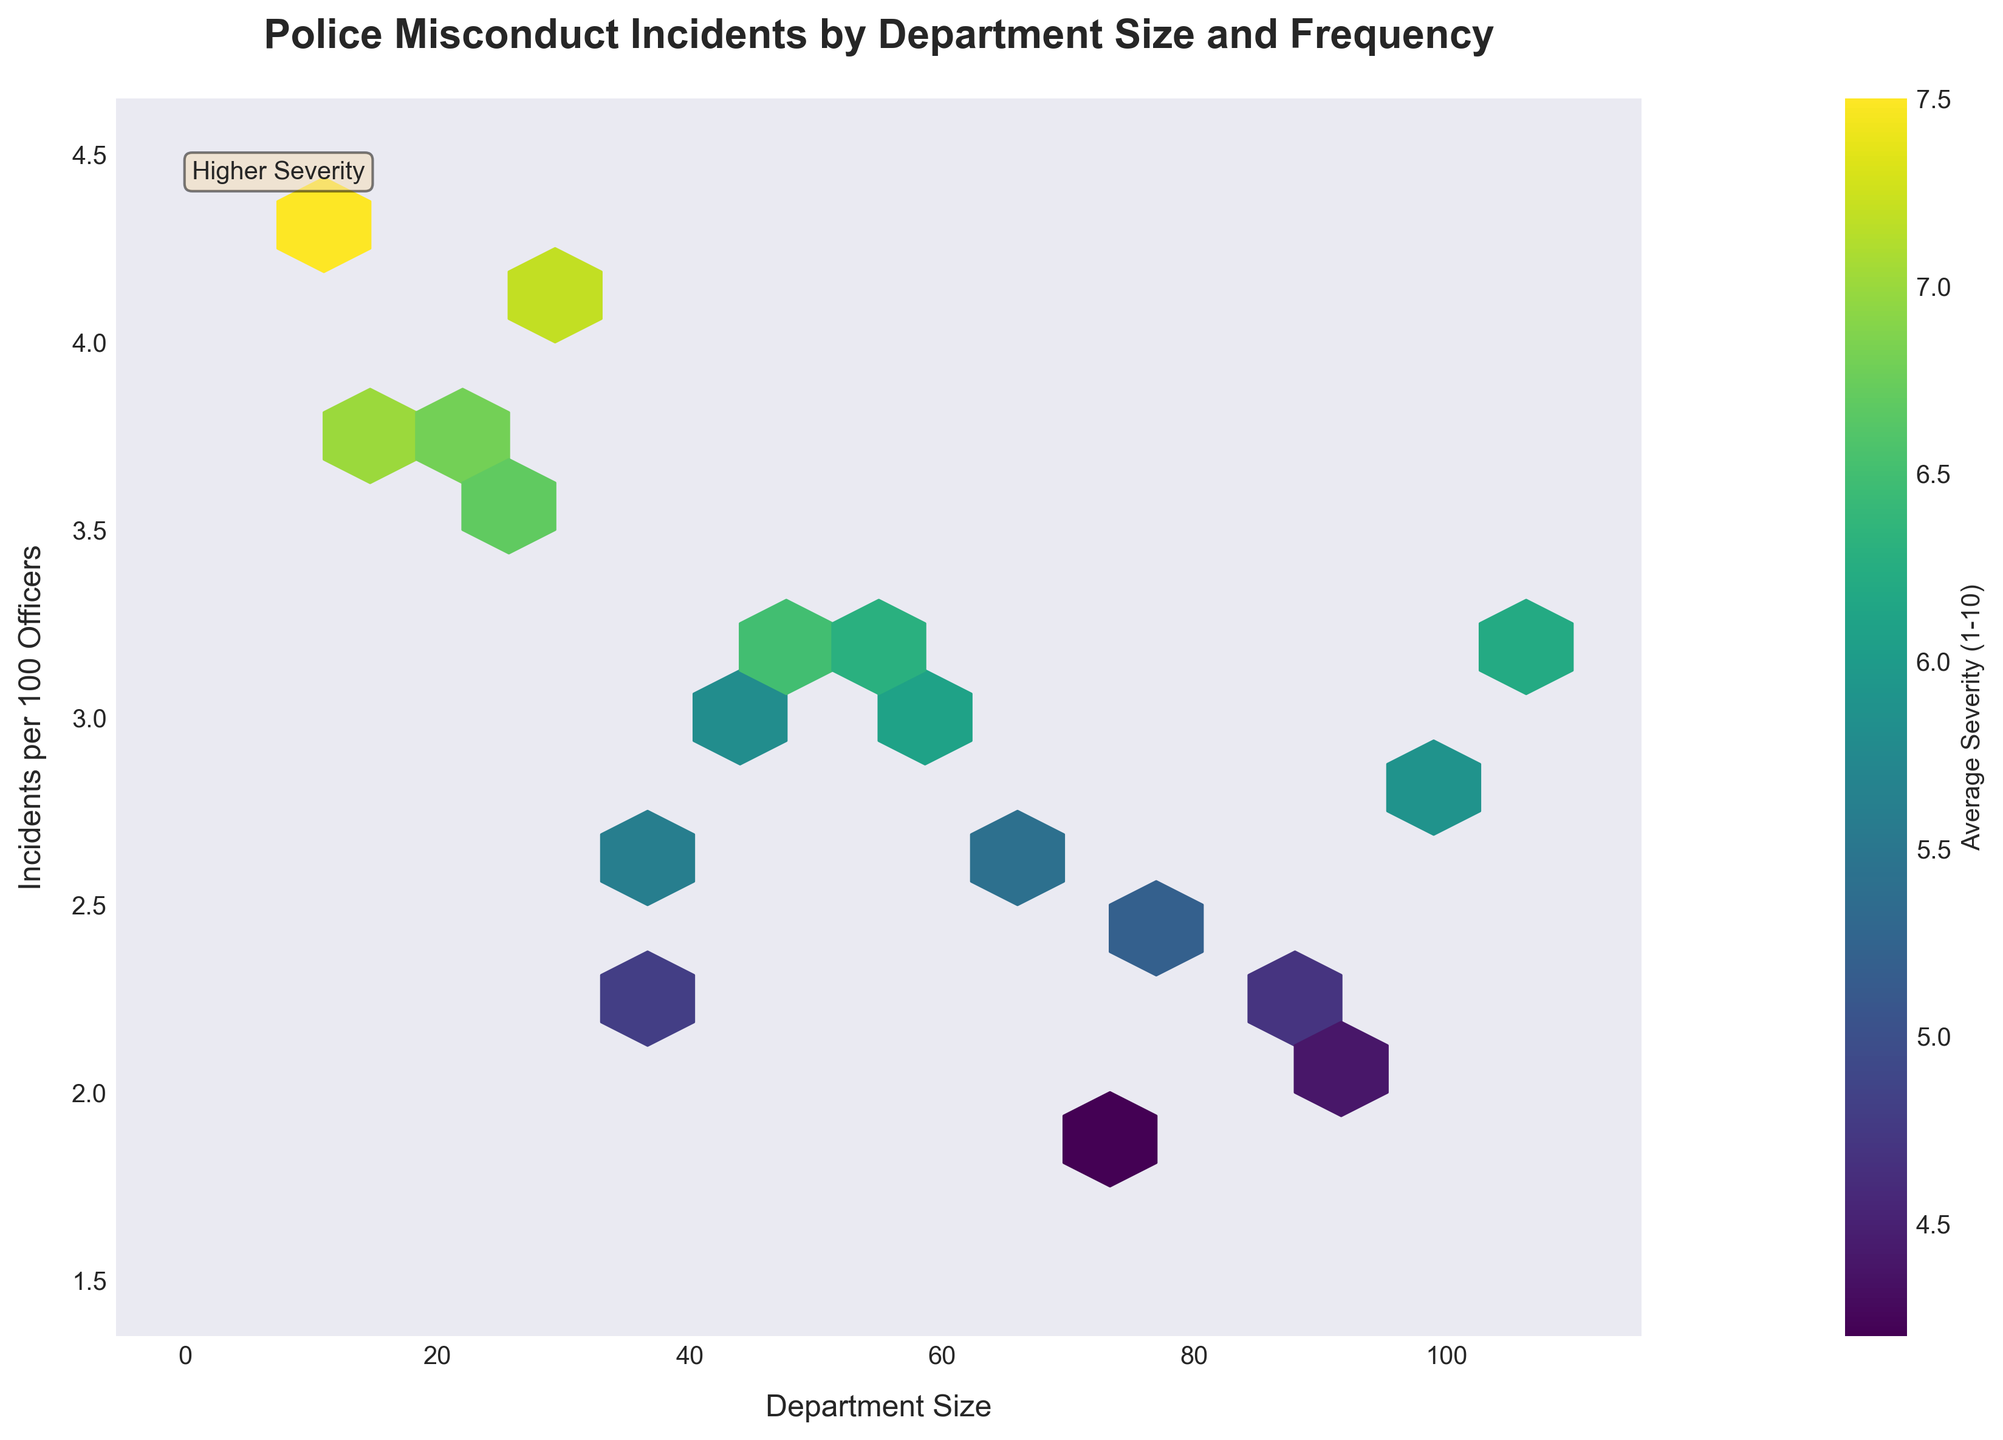What is the title of the figure? The title is typically displayed at the top of the figure, summarizing the main subject of the plot.
Answer: Police Misconduct Incidents by Department Size and Frequency What is the color used to indicate higher severity? Observing the color bar on the right side of the plot will show the gradient of colors representing different severities. The color for higher severity is usually darker or more intense.
Answer: Dark purple What are the axes labels? The labels on the axes are usually positioned next to the axes themselves and explain what each axis represents.
Answer: Department Size (x-axis), Incidents per 100 Officers (y-axis) Between which two values is the frequency of incidents per 100 officers mostly distributed? Check the density of hexagons along the y-axis which indicates the frequency of incidents per 100 officers.
Answer: 2 to 4 Which department size corresponds to the highest average severity? Look for the darkest hexagons on the plot and match them with their department size on the x-axis.
Answer: Denver (10 officers) Is there a positive or negative correlation between department size and incidents per 100 officers? Observe the general trend of hexagons to see if an increase in department size corresponds with an increase or decrease in incidents per 100 officers.
Answer: Negative correlation Which department size range (large or small) tends to have higher severity of incidents? Compare the color distribution across the hexagons, noting which side of the plot has darker colors.
Answer: Small department sizes Do smaller or larger departments have more variability in severity of incidents? Look at the range of colors (indicating severity) in regions representing smaller versus larger department sizes.
Answer: Smaller departments Summarize the correlation between department size and average severity of incidents. Assess the color gradient and hexagons' density throughout the plot. Higher average severity is observed in hexagons toward smaller department sizes (left side of the plot). Towards the larger department sizes (right side), the colors indicate lower severity, showing a negative correlation.
Answer: Negative correlation between department size and average severity Which department size has the least incidents per 100 officers? Find the hexagons closest to the bottom left of the plot, indicating lower values in both department size and incidents per 100 officers.
Answer: San Diego (70 officers) 